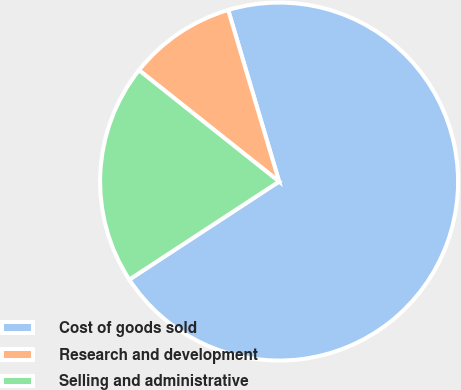Convert chart to OTSL. <chart><loc_0><loc_0><loc_500><loc_500><pie_chart><fcel>Cost of goods sold<fcel>Research and development<fcel>Selling and administrative<nl><fcel>70.38%<fcel>9.72%<fcel>19.91%<nl></chart> 